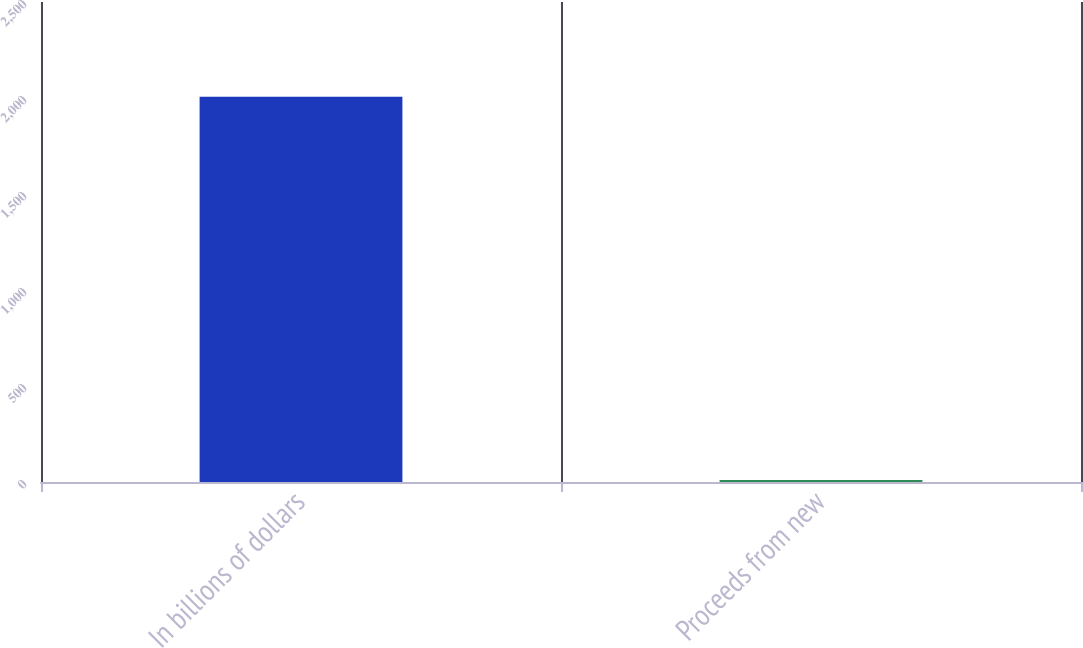Convert chart. <chart><loc_0><loc_0><loc_500><loc_500><bar_chart><fcel>In billions of dollars<fcel>Proceeds from new<nl><fcel>2007<fcel>10.5<nl></chart> 